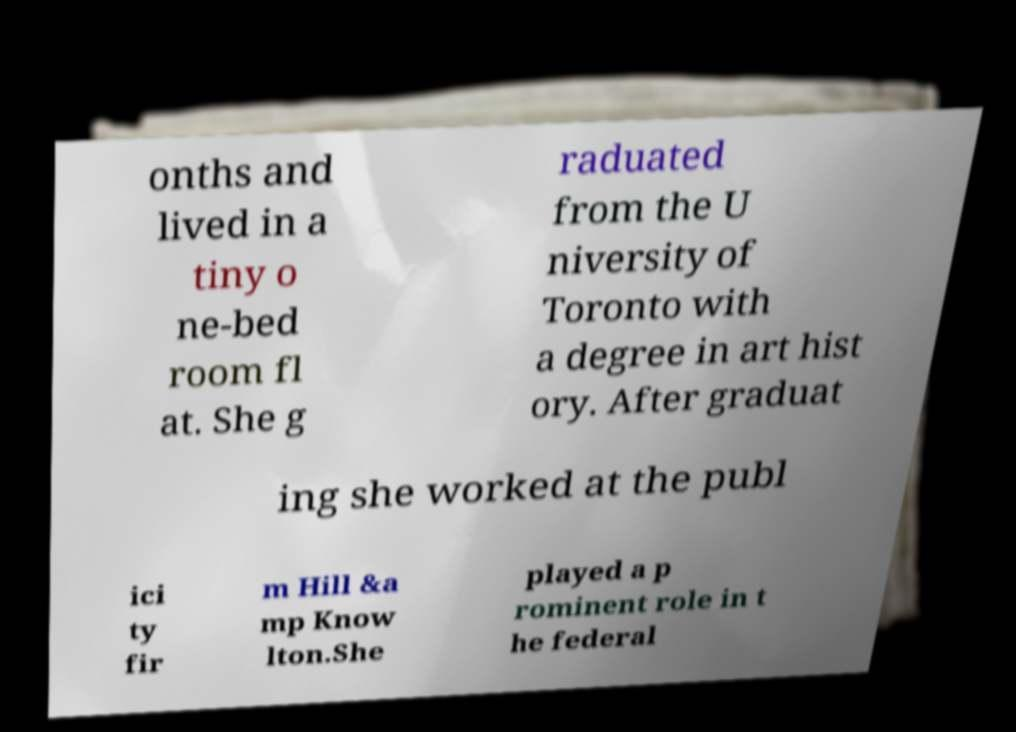There's text embedded in this image that I need extracted. Can you transcribe it verbatim? onths and lived in a tiny o ne-bed room fl at. She g raduated from the U niversity of Toronto with a degree in art hist ory. After graduat ing she worked at the publ ici ty fir m Hill &a mp Know lton.She played a p rominent role in t he federal 